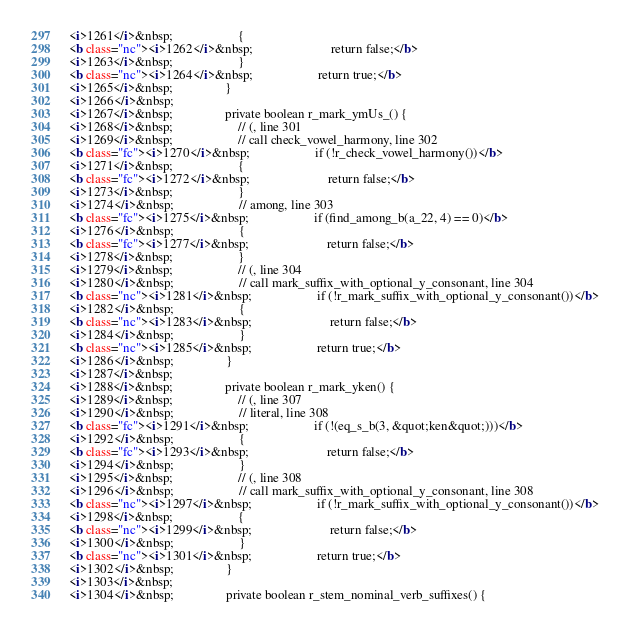<code> <loc_0><loc_0><loc_500><loc_500><_HTML_><i>1261</i>&nbsp;                    {
<b class="nc"><i>1262</i>&nbsp;                        return false;</b>
<i>1263</i>&nbsp;                    }
<b class="nc"><i>1264</i>&nbsp;                    return true;</b>
<i>1265</i>&nbsp;                }
<i>1266</i>&nbsp;
<i>1267</i>&nbsp;                private boolean r_mark_ymUs_() {
<i>1268</i>&nbsp;                    // (, line 301
<i>1269</i>&nbsp;                    // call check_vowel_harmony, line 302
<b class="fc"><i>1270</i>&nbsp;                    if (!r_check_vowel_harmony())</b>
<i>1271</i>&nbsp;                    {
<b class="fc"><i>1272</i>&nbsp;                        return false;</b>
<i>1273</i>&nbsp;                    }
<i>1274</i>&nbsp;                    // among, line 303
<b class="fc"><i>1275</i>&nbsp;                    if (find_among_b(a_22, 4) == 0)</b>
<i>1276</i>&nbsp;                    {
<b class="fc"><i>1277</i>&nbsp;                        return false;</b>
<i>1278</i>&nbsp;                    }
<i>1279</i>&nbsp;                    // (, line 304
<i>1280</i>&nbsp;                    // call mark_suffix_with_optional_y_consonant, line 304
<b class="nc"><i>1281</i>&nbsp;                    if (!r_mark_suffix_with_optional_y_consonant())</b>
<i>1282</i>&nbsp;                    {
<b class="nc"><i>1283</i>&nbsp;                        return false;</b>
<i>1284</i>&nbsp;                    }
<b class="nc"><i>1285</i>&nbsp;                    return true;</b>
<i>1286</i>&nbsp;                }
<i>1287</i>&nbsp;
<i>1288</i>&nbsp;                private boolean r_mark_yken() {
<i>1289</i>&nbsp;                    // (, line 307
<i>1290</i>&nbsp;                    // literal, line 308
<b class="fc"><i>1291</i>&nbsp;                    if (!(eq_s_b(3, &quot;ken&quot;)))</b>
<i>1292</i>&nbsp;                    {
<b class="fc"><i>1293</i>&nbsp;                        return false;</b>
<i>1294</i>&nbsp;                    }
<i>1295</i>&nbsp;                    // (, line 308
<i>1296</i>&nbsp;                    // call mark_suffix_with_optional_y_consonant, line 308
<b class="nc"><i>1297</i>&nbsp;                    if (!r_mark_suffix_with_optional_y_consonant())</b>
<i>1298</i>&nbsp;                    {
<b class="nc"><i>1299</i>&nbsp;                        return false;</b>
<i>1300</i>&nbsp;                    }
<b class="nc"><i>1301</i>&nbsp;                    return true;</b>
<i>1302</i>&nbsp;                }
<i>1303</i>&nbsp;
<i>1304</i>&nbsp;                private boolean r_stem_nominal_verb_suffixes() {</code> 